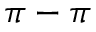Convert formula to latex. <formula><loc_0><loc_0><loc_500><loc_500>\pi - \pi</formula> 